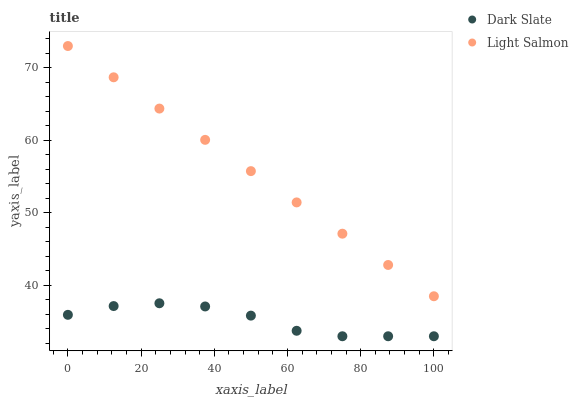Does Dark Slate have the minimum area under the curve?
Answer yes or no. Yes. Does Light Salmon have the maximum area under the curve?
Answer yes or no. Yes. Does Light Salmon have the minimum area under the curve?
Answer yes or no. No. Is Light Salmon the smoothest?
Answer yes or no. Yes. Is Dark Slate the roughest?
Answer yes or no. Yes. Is Light Salmon the roughest?
Answer yes or no. No. Does Dark Slate have the lowest value?
Answer yes or no. Yes. Does Light Salmon have the lowest value?
Answer yes or no. No. Does Light Salmon have the highest value?
Answer yes or no. Yes. Is Dark Slate less than Light Salmon?
Answer yes or no. Yes. Is Light Salmon greater than Dark Slate?
Answer yes or no. Yes. Does Dark Slate intersect Light Salmon?
Answer yes or no. No. 